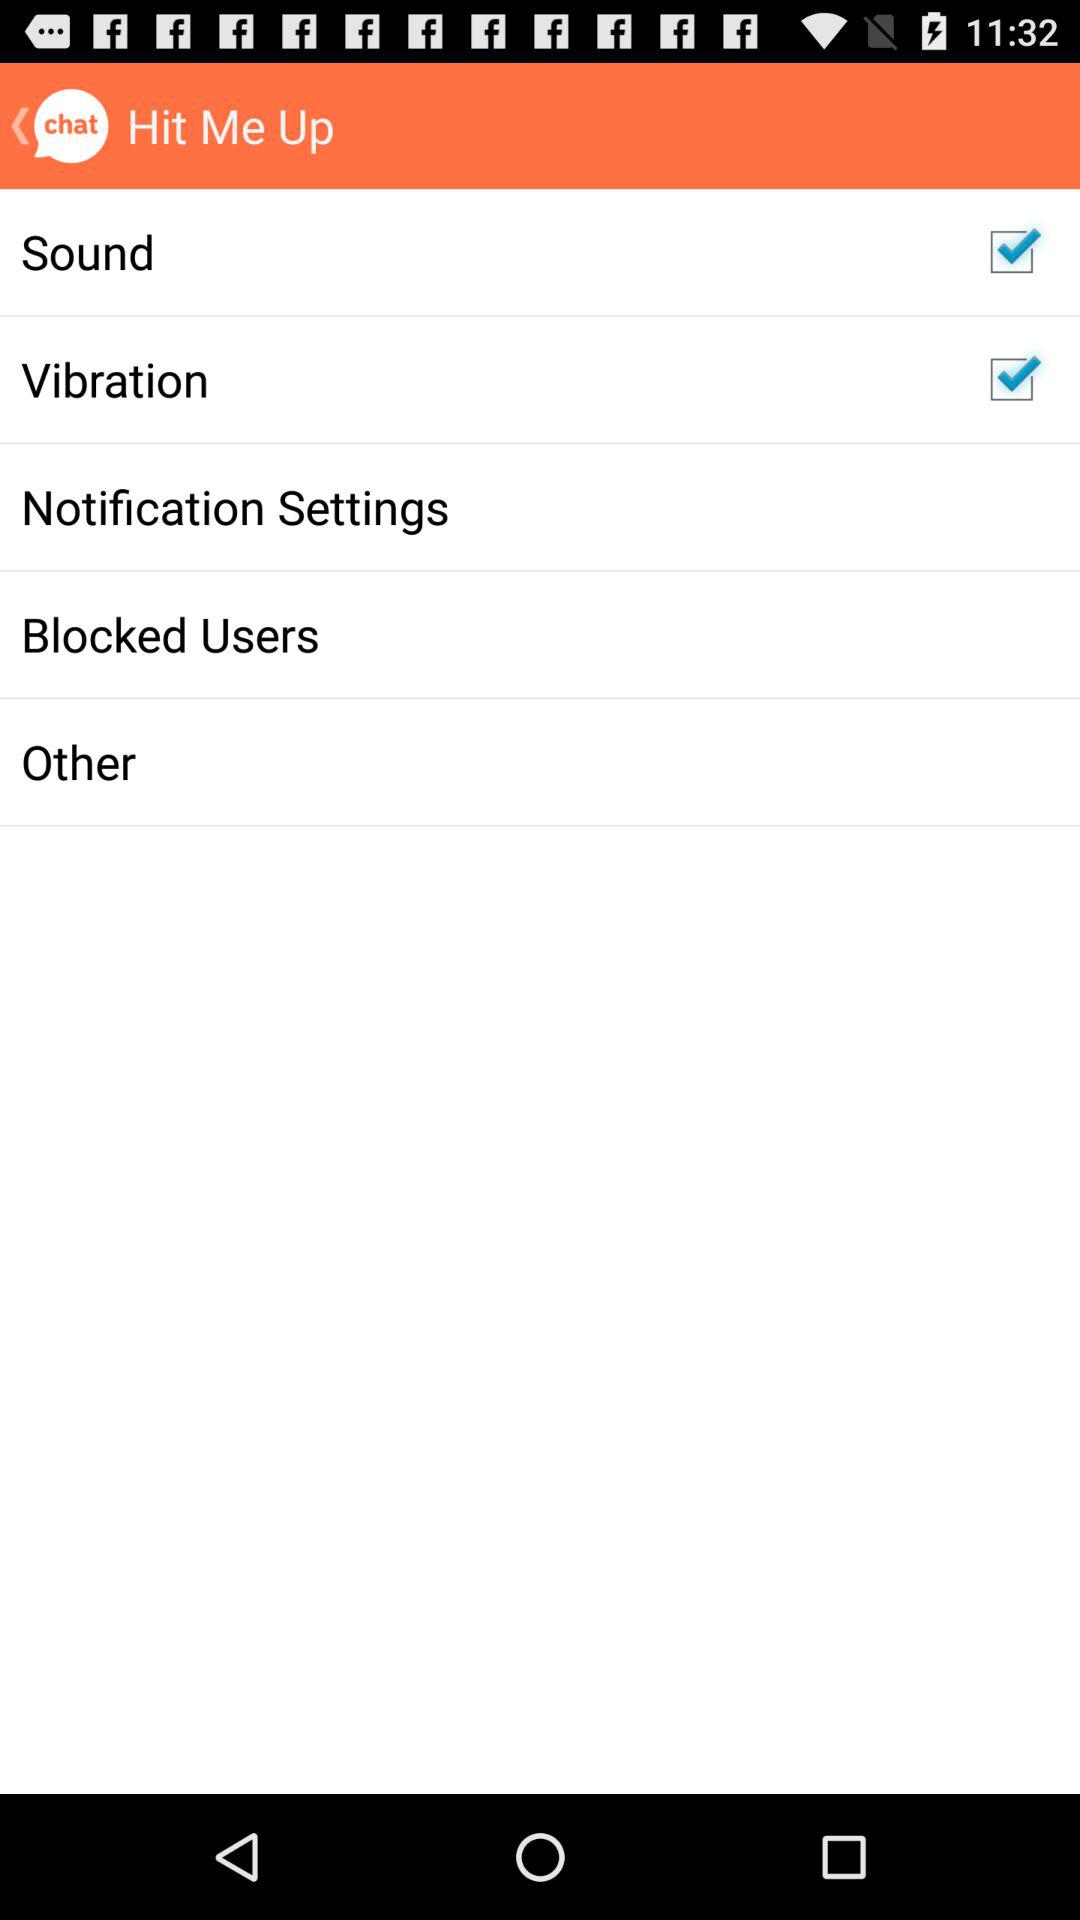What is the app name? The app name is "Hit Me Up". 